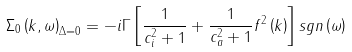Convert formula to latex. <formula><loc_0><loc_0><loc_500><loc_500>\Sigma _ { 0 } \left ( { k } , \omega \right ) _ { \Delta = 0 } = - i \Gamma \left [ \frac { 1 } { c ^ { 2 } _ { i } + 1 } + \frac { 1 } { c ^ { 2 } _ { a } + 1 } f ^ { 2 } \left ( { k } \right ) \right ] s g n \left ( \omega \right )</formula> 